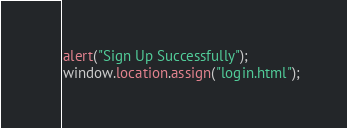Convert code to text. <code><loc_0><loc_0><loc_500><loc_500><_JavaScript_>alert("Sign Up Successfully");
window.location.assign("login.html");</code> 